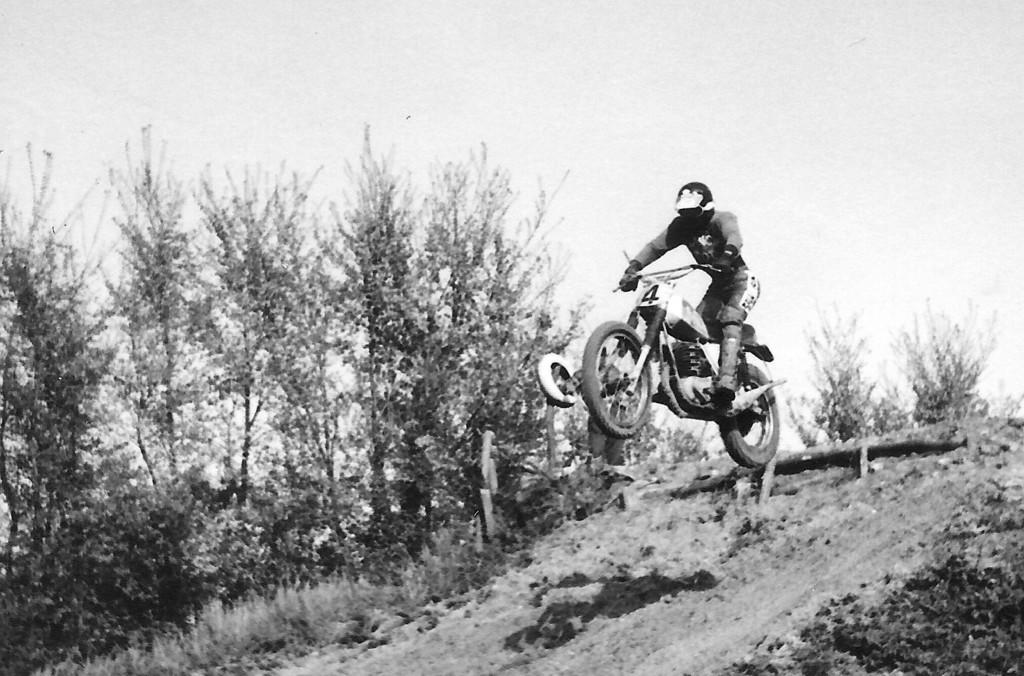What is the main subject of the image? There is a person in the image. What is the person doing in the image? The person is in the air with a bike. What safety gear is the person wearing? The person is wearing a helmet. What type of vegetation can be seen in the background of the image? There are plants and trees in the background of the image. What is visible at the top of the image? The sky is visible at the top of the image. How many mice are sitting on the rock in the image? There is no rock or mice present in the image. What type of picture is hanging on the wall in the image? There is no wall or picture present in the image. 